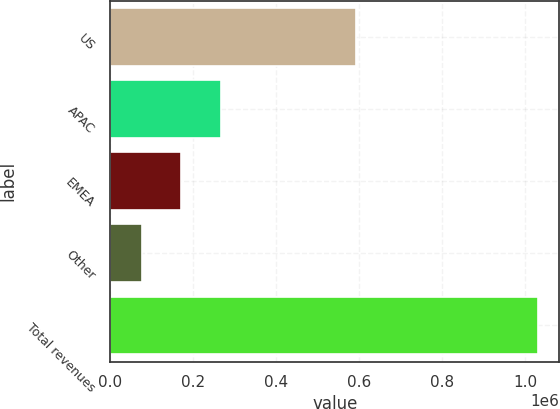Convert chart to OTSL. <chart><loc_0><loc_0><loc_500><loc_500><bar_chart><fcel>US<fcel>APAC<fcel>EMEA<fcel>Other<fcel>Total revenues<nl><fcel>592774<fcel>266720<fcel>171232<fcel>75745<fcel>1.03062e+06<nl></chart> 